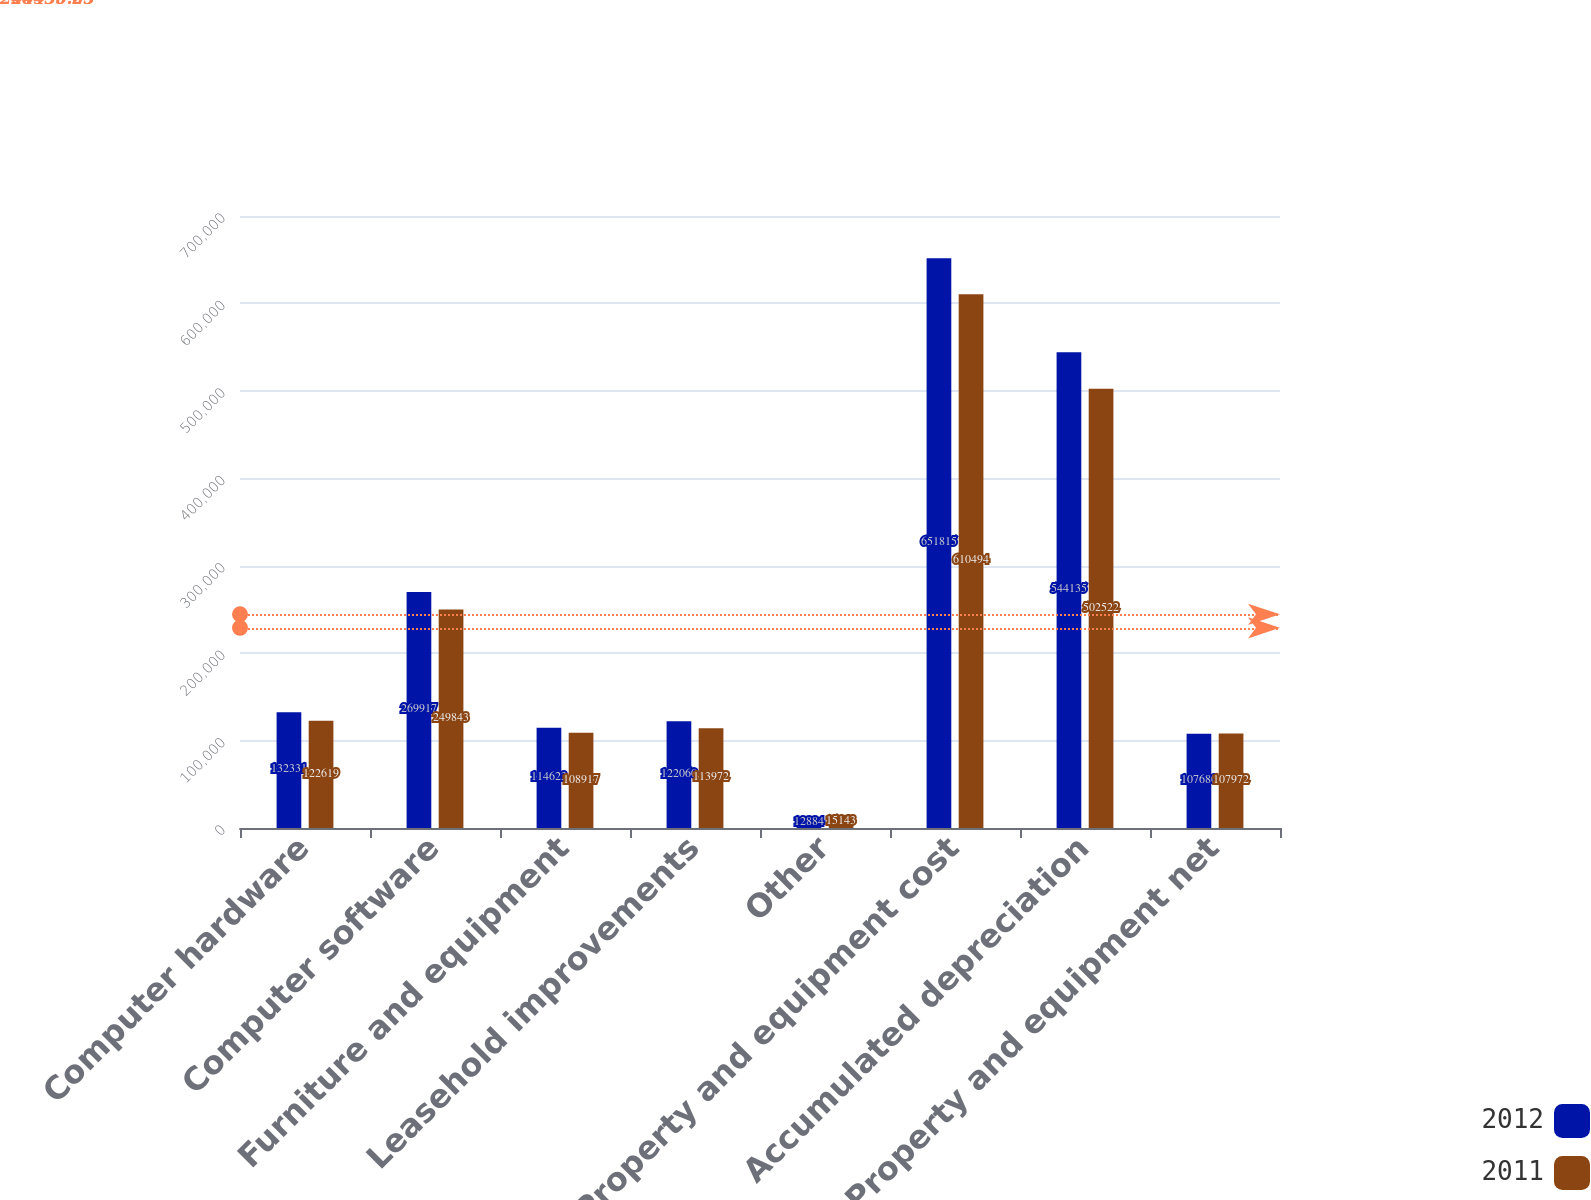<chart> <loc_0><loc_0><loc_500><loc_500><stacked_bar_chart><ecel><fcel>Computer hardware<fcel>Computer software<fcel>Furniture and equipment<fcel>Leasehold improvements<fcel>Other<fcel>Property and equipment cost<fcel>Accumulated depreciation<fcel>Property and equipment net<nl><fcel>2012<fcel>132331<fcel>269917<fcel>114623<fcel>122060<fcel>12884<fcel>651815<fcel>544135<fcel>107680<nl><fcel>2011<fcel>122619<fcel>249843<fcel>108917<fcel>113972<fcel>15143<fcel>610494<fcel>502522<fcel>107972<nl></chart> 